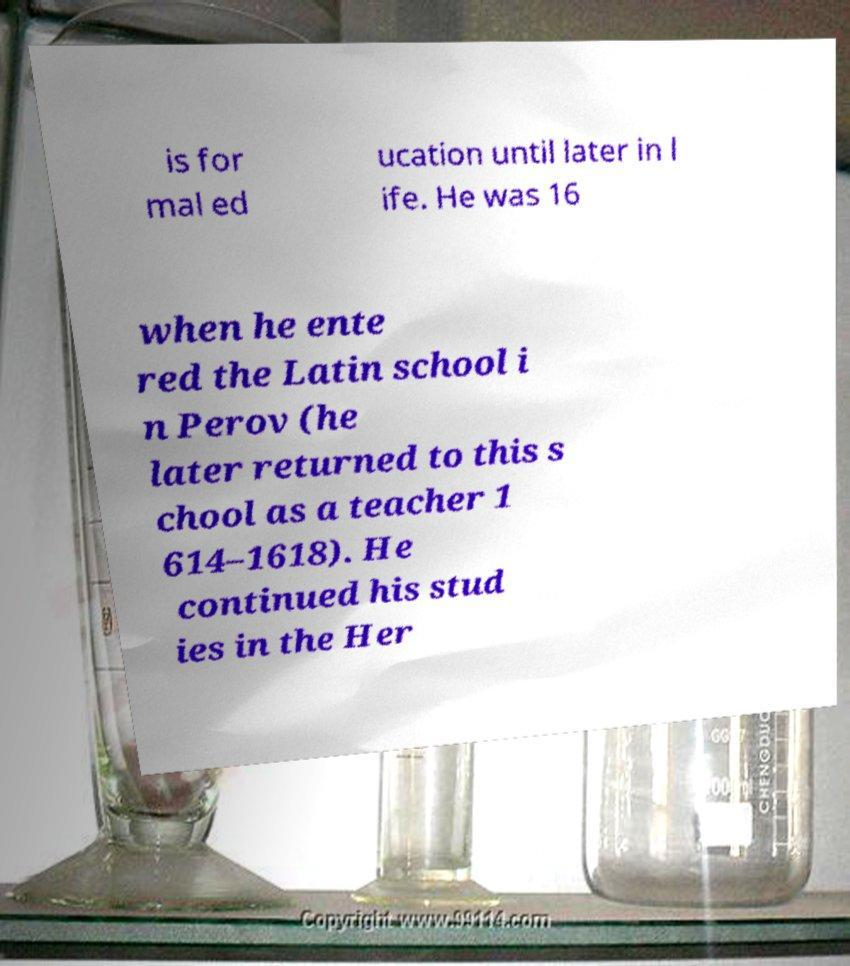Please identify and transcribe the text found in this image. is for mal ed ucation until later in l ife. He was 16 when he ente red the Latin school i n Perov (he later returned to this s chool as a teacher 1 614–1618). He continued his stud ies in the Her 